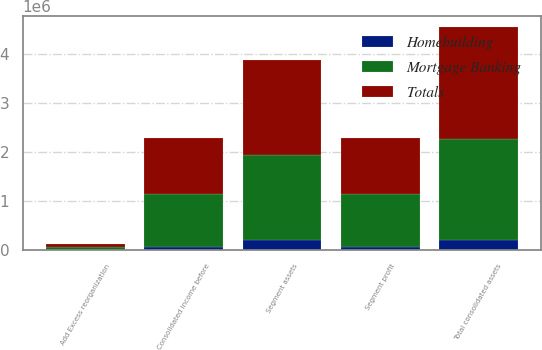Convert chart to OTSL. <chart><loc_0><loc_0><loc_500><loc_500><stacked_bar_chart><ecel><fcel>Segment profit<fcel>Consolidated income before<fcel>Segment assets<fcel>Add Excess reorganization<fcel>Total consolidated assets<nl><fcel>Mortgage Banking<fcel>1.0868e+06<fcel>1.08668e+06<fcel>1.72773e+06<fcel>53641<fcel>2.05668e+06<nl><fcel>Homebuilding<fcel>57739<fcel>57739<fcel>205560<fcel>7347<fcel>212907<nl><fcel>Totals<fcel>1.14454e+06<fcel>1.14442e+06<fcel>1.93329e+06<fcel>60988<fcel>2.26959e+06<nl></chart> 